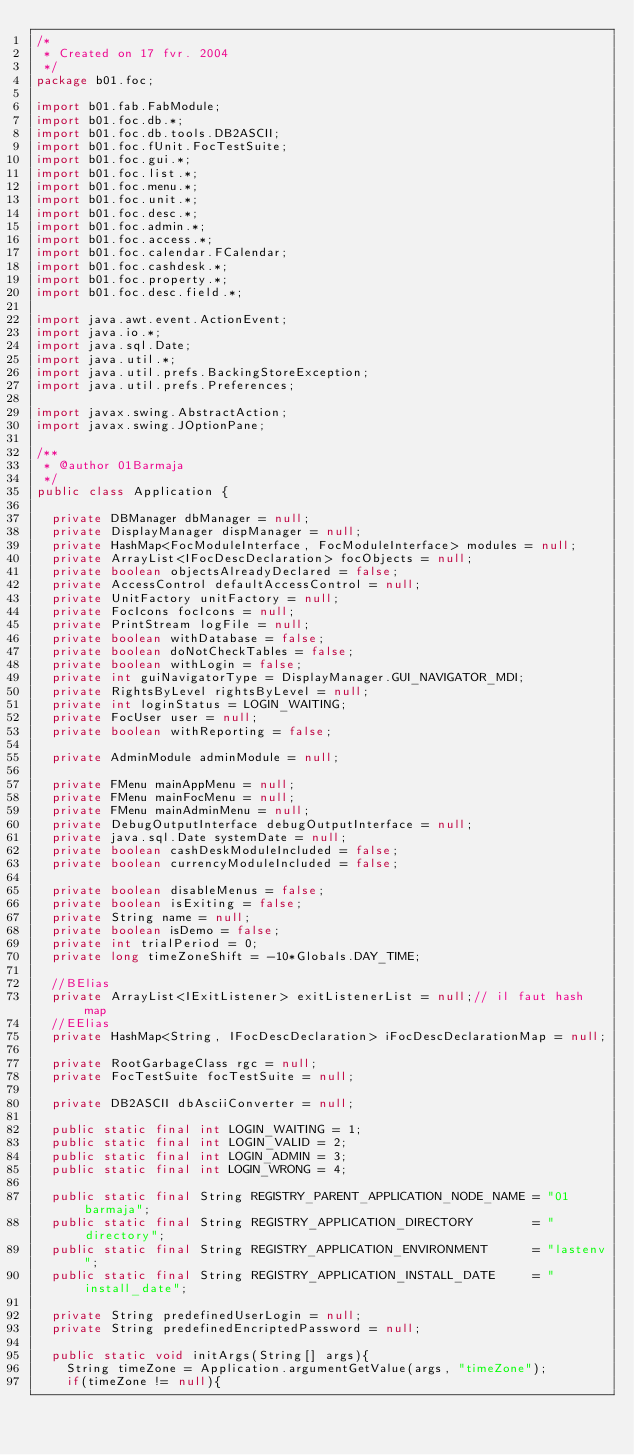<code> <loc_0><loc_0><loc_500><loc_500><_Java_>/*
 * Created on 17 fvr. 2004
 */
package b01.foc;

import b01.fab.FabModule;
import b01.foc.db.*;
import b01.foc.db.tools.DB2ASCII;
import b01.foc.fUnit.FocTestSuite;
import b01.foc.gui.*;
import b01.foc.list.*;
import b01.foc.menu.*;
import b01.foc.unit.*;
import b01.foc.desc.*;
import b01.foc.admin.*;
import b01.foc.access.*;
import b01.foc.calendar.FCalendar;
import b01.foc.cashdesk.*;
import b01.foc.property.*;
import b01.foc.desc.field.*;

import java.awt.event.ActionEvent;
import java.io.*;
import java.sql.Date;
import java.util.*;
import java.util.prefs.BackingStoreException;
import java.util.prefs.Preferences;

import javax.swing.AbstractAction;
import javax.swing.JOptionPane;

/**
 * @author 01Barmaja
 */
public class Application {

  private DBManager dbManager = null;
  private DisplayManager dispManager = null;
  private HashMap<FocModuleInterface, FocModuleInterface> modules = null;
  private ArrayList<IFocDescDeclaration> focObjects = null;  
  private boolean objectsAlreadyDeclared = false; 
  private AccessControl defaultAccessControl = null;
  private UnitFactory unitFactory = null;
  private FocIcons focIcons = null;
  private PrintStream logFile = null;
  private boolean withDatabase = false;
  private boolean doNotCheckTables = false;
  private boolean withLogin = false;
  private int guiNavigatorType = DisplayManager.GUI_NAVIGATOR_MDI;
  private RightsByLevel rightsByLevel = null;
  private int loginStatus = LOGIN_WAITING;
  private FocUser user = null;
  private boolean withReporting = false;
  
  private AdminModule adminModule = null;
  
  private FMenu mainAppMenu = null;
  private FMenu mainFocMenu = null;  
  private FMenu mainAdminMenu = null;
  private DebugOutputInterface debugOutputInterface = null;
  private java.sql.Date systemDate = null;
  private boolean cashDeskModuleIncluded = false; 
  private boolean currencyModuleIncluded = false;
  
  private boolean disableMenus = false;
  private boolean isExiting = false;
  private String name = null;
  private boolean isDemo = false;
  private int trialPeriod = 0;
  private long timeZoneShift = -10*Globals.DAY_TIME;
  
  //BElias
  private ArrayList<IExitListener> exitListenerList = null;// il faut hash map
  //EElias
  private HashMap<String, IFocDescDeclaration> iFocDescDeclarationMap = null;
  
  private RootGarbageClass rgc = null;
  private FocTestSuite focTestSuite = null;
  
  private DB2ASCII dbAsciiConverter = null;
    
  public static final int LOGIN_WAITING = 1;
  public static final int LOGIN_VALID = 2;
  public static final int LOGIN_ADMIN = 3;  
  public static final int LOGIN_WRONG = 4;
  
  public static final String REGISTRY_PARENT_APPLICATION_NODE_NAME = "01barmaja";
  public static final String REGISTRY_APPLICATION_DIRECTORY        = "directory";
  public static final String REGISTRY_APPLICATION_ENVIRONMENT      = "lastenv";
  public static final String REGISTRY_APPLICATION_INSTALL_DATE     = "install_date";
  
  private String predefinedUserLogin = null;
  private String predefinedEncriptedPassword = null;
  
  public static void initArgs(String[] args){
  	String timeZone = Application.argumentGetValue(args, "timeZone");
  	if(timeZone != null){</code> 